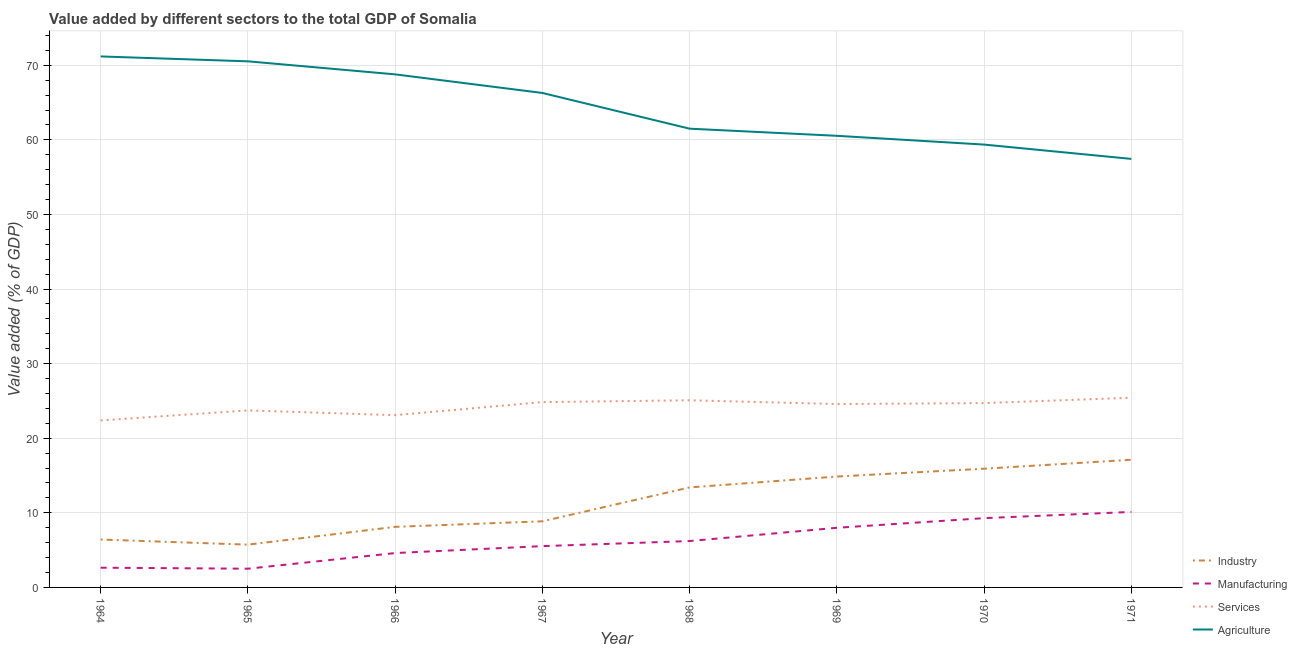How many different coloured lines are there?
Your response must be concise. 4. Does the line corresponding to value added by industrial sector intersect with the line corresponding to value added by manufacturing sector?
Keep it short and to the point. No. What is the value added by manufacturing sector in 1965?
Make the answer very short. 2.51. Across all years, what is the maximum value added by industrial sector?
Make the answer very short. 17.12. Across all years, what is the minimum value added by agricultural sector?
Give a very brief answer. 57.45. In which year was the value added by industrial sector maximum?
Make the answer very short. 1971. In which year was the value added by services sector minimum?
Give a very brief answer. 1964. What is the total value added by agricultural sector in the graph?
Your answer should be very brief. 515.66. What is the difference between the value added by services sector in 1965 and that in 1968?
Provide a succinct answer. -1.36. What is the difference between the value added by manufacturing sector in 1967 and the value added by services sector in 1970?
Your answer should be very brief. -19.17. What is the average value added by agricultural sector per year?
Provide a succinct answer. 64.46. In the year 1966, what is the difference between the value added by industrial sector and value added by services sector?
Provide a succinct answer. -14.97. What is the ratio of the value added by industrial sector in 1967 to that in 1970?
Ensure brevity in your answer.  0.56. What is the difference between the highest and the second highest value added by manufacturing sector?
Offer a very short reply. 0.83. What is the difference between the highest and the lowest value added by manufacturing sector?
Keep it short and to the point. 7.61. Is the sum of the value added by agricultural sector in 1964 and 1970 greater than the maximum value added by manufacturing sector across all years?
Provide a succinct answer. Yes. Is it the case that in every year, the sum of the value added by industrial sector and value added by agricultural sector is greater than the sum of value added by services sector and value added by manufacturing sector?
Provide a succinct answer. No. Does the value added by manufacturing sector monotonically increase over the years?
Your answer should be very brief. No. Are the values on the major ticks of Y-axis written in scientific E-notation?
Provide a succinct answer. No. Does the graph contain any zero values?
Make the answer very short. No. Does the graph contain grids?
Your answer should be compact. Yes. How many legend labels are there?
Make the answer very short. 4. What is the title of the graph?
Your response must be concise. Value added by different sectors to the total GDP of Somalia. Does "Japan" appear as one of the legend labels in the graph?
Make the answer very short. No. What is the label or title of the Y-axis?
Provide a short and direct response. Value added (% of GDP). What is the Value added (% of GDP) of Industry in 1964?
Provide a succinct answer. 6.42. What is the Value added (% of GDP) in Manufacturing in 1964?
Provide a succinct answer. 2.65. What is the Value added (% of GDP) in Services in 1964?
Make the answer very short. 22.39. What is the Value added (% of GDP) of Agriculture in 1964?
Make the answer very short. 71.19. What is the Value added (% of GDP) in Industry in 1965?
Give a very brief answer. 5.74. What is the Value added (% of GDP) in Manufacturing in 1965?
Give a very brief answer. 2.51. What is the Value added (% of GDP) of Services in 1965?
Provide a short and direct response. 23.73. What is the Value added (% of GDP) in Agriculture in 1965?
Offer a very short reply. 70.53. What is the Value added (% of GDP) in Industry in 1966?
Offer a very short reply. 8.12. What is the Value added (% of GDP) of Manufacturing in 1966?
Your response must be concise. 4.61. What is the Value added (% of GDP) in Services in 1966?
Give a very brief answer. 23.1. What is the Value added (% of GDP) in Agriculture in 1966?
Make the answer very short. 68.78. What is the Value added (% of GDP) of Industry in 1967?
Make the answer very short. 8.86. What is the Value added (% of GDP) of Manufacturing in 1967?
Offer a very short reply. 5.54. What is the Value added (% of GDP) in Services in 1967?
Make the answer very short. 24.85. What is the Value added (% of GDP) of Agriculture in 1967?
Your answer should be very brief. 66.29. What is the Value added (% of GDP) in Industry in 1968?
Provide a short and direct response. 13.41. What is the Value added (% of GDP) in Manufacturing in 1968?
Your answer should be compact. 6.22. What is the Value added (% of GDP) of Services in 1968?
Offer a terse response. 25.09. What is the Value added (% of GDP) in Agriculture in 1968?
Offer a very short reply. 61.5. What is the Value added (% of GDP) of Industry in 1969?
Your answer should be compact. 14.87. What is the Value added (% of GDP) in Manufacturing in 1969?
Make the answer very short. 7.99. What is the Value added (% of GDP) of Services in 1969?
Make the answer very short. 24.59. What is the Value added (% of GDP) in Agriculture in 1969?
Ensure brevity in your answer.  60.55. What is the Value added (% of GDP) of Industry in 1970?
Provide a short and direct response. 15.92. What is the Value added (% of GDP) of Manufacturing in 1970?
Keep it short and to the point. 9.29. What is the Value added (% of GDP) of Services in 1970?
Offer a very short reply. 24.71. What is the Value added (% of GDP) in Agriculture in 1970?
Offer a very short reply. 59.37. What is the Value added (% of GDP) of Industry in 1971?
Your response must be concise. 17.12. What is the Value added (% of GDP) of Manufacturing in 1971?
Ensure brevity in your answer.  10.12. What is the Value added (% of GDP) in Services in 1971?
Ensure brevity in your answer.  25.43. What is the Value added (% of GDP) in Agriculture in 1971?
Ensure brevity in your answer.  57.45. Across all years, what is the maximum Value added (% of GDP) of Industry?
Make the answer very short. 17.12. Across all years, what is the maximum Value added (% of GDP) of Manufacturing?
Give a very brief answer. 10.12. Across all years, what is the maximum Value added (% of GDP) of Services?
Ensure brevity in your answer.  25.43. Across all years, what is the maximum Value added (% of GDP) of Agriculture?
Ensure brevity in your answer.  71.19. Across all years, what is the minimum Value added (% of GDP) in Industry?
Offer a very short reply. 5.74. Across all years, what is the minimum Value added (% of GDP) of Manufacturing?
Make the answer very short. 2.51. Across all years, what is the minimum Value added (% of GDP) in Services?
Provide a succinct answer. 22.39. Across all years, what is the minimum Value added (% of GDP) in Agriculture?
Your response must be concise. 57.45. What is the total Value added (% of GDP) of Industry in the graph?
Your answer should be compact. 90.45. What is the total Value added (% of GDP) of Manufacturing in the graph?
Offer a terse response. 48.92. What is the total Value added (% of GDP) in Services in the graph?
Provide a succinct answer. 193.89. What is the total Value added (% of GDP) in Agriculture in the graph?
Offer a terse response. 515.66. What is the difference between the Value added (% of GDP) of Industry in 1964 and that in 1965?
Your answer should be compact. 0.69. What is the difference between the Value added (% of GDP) in Manufacturing in 1964 and that in 1965?
Give a very brief answer. 0.14. What is the difference between the Value added (% of GDP) of Services in 1964 and that in 1965?
Give a very brief answer. -1.34. What is the difference between the Value added (% of GDP) of Agriculture in 1964 and that in 1965?
Make the answer very short. 0.65. What is the difference between the Value added (% of GDP) in Industry in 1964 and that in 1966?
Give a very brief answer. -1.7. What is the difference between the Value added (% of GDP) in Manufacturing in 1964 and that in 1966?
Offer a very short reply. -1.96. What is the difference between the Value added (% of GDP) of Services in 1964 and that in 1966?
Offer a terse response. -0.7. What is the difference between the Value added (% of GDP) in Agriculture in 1964 and that in 1966?
Provide a short and direct response. 2.4. What is the difference between the Value added (% of GDP) of Industry in 1964 and that in 1967?
Your answer should be very brief. -2.44. What is the difference between the Value added (% of GDP) in Manufacturing in 1964 and that in 1967?
Your answer should be very brief. -2.89. What is the difference between the Value added (% of GDP) of Services in 1964 and that in 1967?
Your answer should be very brief. -2.45. What is the difference between the Value added (% of GDP) in Agriculture in 1964 and that in 1967?
Make the answer very short. 4.9. What is the difference between the Value added (% of GDP) in Industry in 1964 and that in 1968?
Provide a succinct answer. -6.99. What is the difference between the Value added (% of GDP) of Manufacturing in 1964 and that in 1968?
Provide a succinct answer. -3.57. What is the difference between the Value added (% of GDP) in Services in 1964 and that in 1968?
Offer a very short reply. -2.7. What is the difference between the Value added (% of GDP) in Agriculture in 1964 and that in 1968?
Provide a succinct answer. 9.68. What is the difference between the Value added (% of GDP) of Industry in 1964 and that in 1969?
Your answer should be compact. -8.45. What is the difference between the Value added (% of GDP) in Manufacturing in 1964 and that in 1969?
Offer a terse response. -5.35. What is the difference between the Value added (% of GDP) of Services in 1964 and that in 1969?
Make the answer very short. -2.2. What is the difference between the Value added (% of GDP) of Agriculture in 1964 and that in 1969?
Provide a succinct answer. 10.64. What is the difference between the Value added (% of GDP) of Industry in 1964 and that in 1970?
Ensure brevity in your answer.  -9.5. What is the difference between the Value added (% of GDP) of Manufacturing in 1964 and that in 1970?
Provide a succinct answer. -6.64. What is the difference between the Value added (% of GDP) of Services in 1964 and that in 1970?
Your answer should be compact. -2.32. What is the difference between the Value added (% of GDP) in Agriculture in 1964 and that in 1970?
Offer a terse response. 11.82. What is the difference between the Value added (% of GDP) of Industry in 1964 and that in 1971?
Ensure brevity in your answer.  -10.69. What is the difference between the Value added (% of GDP) in Manufacturing in 1964 and that in 1971?
Offer a very short reply. -7.48. What is the difference between the Value added (% of GDP) of Services in 1964 and that in 1971?
Offer a very short reply. -3.04. What is the difference between the Value added (% of GDP) of Agriculture in 1964 and that in 1971?
Ensure brevity in your answer.  13.74. What is the difference between the Value added (% of GDP) of Industry in 1965 and that in 1966?
Give a very brief answer. -2.39. What is the difference between the Value added (% of GDP) in Manufacturing in 1965 and that in 1966?
Provide a succinct answer. -2.1. What is the difference between the Value added (% of GDP) in Services in 1965 and that in 1966?
Provide a short and direct response. 0.64. What is the difference between the Value added (% of GDP) of Agriculture in 1965 and that in 1966?
Your response must be concise. 1.75. What is the difference between the Value added (% of GDP) in Industry in 1965 and that in 1967?
Your answer should be very brief. -3.13. What is the difference between the Value added (% of GDP) in Manufacturing in 1965 and that in 1967?
Your response must be concise. -3.03. What is the difference between the Value added (% of GDP) of Services in 1965 and that in 1967?
Provide a short and direct response. -1.11. What is the difference between the Value added (% of GDP) of Agriculture in 1965 and that in 1967?
Ensure brevity in your answer.  4.24. What is the difference between the Value added (% of GDP) in Industry in 1965 and that in 1968?
Provide a short and direct response. -7.67. What is the difference between the Value added (% of GDP) of Manufacturing in 1965 and that in 1968?
Provide a succinct answer. -3.71. What is the difference between the Value added (% of GDP) in Services in 1965 and that in 1968?
Provide a short and direct response. -1.36. What is the difference between the Value added (% of GDP) of Agriculture in 1965 and that in 1968?
Your response must be concise. 9.03. What is the difference between the Value added (% of GDP) of Industry in 1965 and that in 1969?
Give a very brief answer. -9.13. What is the difference between the Value added (% of GDP) of Manufacturing in 1965 and that in 1969?
Your answer should be compact. -5.49. What is the difference between the Value added (% of GDP) of Services in 1965 and that in 1969?
Keep it short and to the point. -0.86. What is the difference between the Value added (% of GDP) of Agriculture in 1965 and that in 1969?
Offer a very short reply. 9.99. What is the difference between the Value added (% of GDP) of Industry in 1965 and that in 1970?
Keep it short and to the point. -10.18. What is the difference between the Value added (% of GDP) in Manufacturing in 1965 and that in 1970?
Give a very brief answer. -6.78. What is the difference between the Value added (% of GDP) of Services in 1965 and that in 1970?
Your answer should be very brief. -0.98. What is the difference between the Value added (% of GDP) in Agriculture in 1965 and that in 1970?
Offer a terse response. 11.16. What is the difference between the Value added (% of GDP) of Industry in 1965 and that in 1971?
Provide a short and direct response. -11.38. What is the difference between the Value added (% of GDP) of Manufacturing in 1965 and that in 1971?
Your response must be concise. -7.61. What is the difference between the Value added (% of GDP) of Services in 1965 and that in 1971?
Ensure brevity in your answer.  -1.7. What is the difference between the Value added (% of GDP) of Agriculture in 1965 and that in 1971?
Give a very brief answer. 13.08. What is the difference between the Value added (% of GDP) in Industry in 1966 and that in 1967?
Offer a very short reply. -0.74. What is the difference between the Value added (% of GDP) in Manufacturing in 1966 and that in 1967?
Give a very brief answer. -0.93. What is the difference between the Value added (% of GDP) in Services in 1966 and that in 1967?
Keep it short and to the point. -1.75. What is the difference between the Value added (% of GDP) of Agriculture in 1966 and that in 1967?
Provide a short and direct response. 2.49. What is the difference between the Value added (% of GDP) in Industry in 1966 and that in 1968?
Provide a short and direct response. -5.29. What is the difference between the Value added (% of GDP) of Manufacturing in 1966 and that in 1968?
Make the answer very short. -1.61. What is the difference between the Value added (% of GDP) in Services in 1966 and that in 1968?
Keep it short and to the point. -1.99. What is the difference between the Value added (% of GDP) of Agriculture in 1966 and that in 1968?
Your response must be concise. 7.28. What is the difference between the Value added (% of GDP) in Industry in 1966 and that in 1969?
Your answer should be compact. -6.74. What is the difference between the Value added (% of GDP) of Manufacturing in 1966 and that in 1969?
Your answer should be compact. -3.39. What is the difference between the Value added (% of GDP) of Services in 1966 and that in 1969?
Your response must be concise. -1.49. What is the difference between the Value added (% of GDP) of Agriculture in 1966 and that in 1969?
Keep it short and to the point. 8.24. What is the difference between the Value added (% of GDP) of Industry in 1966 and that in 1970?
Keep it short and to the point. -7.8. What is the difference between the Value added (% of GDP) of Manufacturing in 1966 and that in 1970?
Provide a short and direct response. -4.68. What is the difference between the Value added (% of GDP) of Services in 1966 and that in 1970?
Your answer should be very brief. -1.62. What is the difference between the Value added (% of GDP) of Agriculture in 1966 and that in 1970?
Give a very brief answer. 9.41. What is the difference between the Value added (% of GDP) in Industry in 1966 and that in 1971?
Your response must be concise. -8.99. What is the difference between the Value added (% of GDP) in Manufacturing in 1966 and that in 1971?
Your answer should be very brief. -5.51. What is the difference between the Value added (% of GDP) of Services in 1966 and that in 1971?
Ensure brevity in your answer.  -2.34. What is the difference between the Value added (% of GDP) in Agriculture in 1966 and that in 1971?
Make the answer very short. 11.33. What is the difference between the Value added (% of GDP) in Industry in 1967 and that in 1968?
Your response must be concise. -4.54. What is the difference between the Value added (% of GDP) of Manufacturing in 1967 and that in 1968?
Offer a terse response. -0.68. What is the difference between the Value added (% of GDP) in Services in 1967 and that in 1968?
Offer a terse response. -0.24. What is the difference between the Value added (% of GDP) in Agriculture in 1967 and that in 1968?
Make the answer very short. 4.79. What is the difference between the Value added (% of GDP) in Industry in 1967 and that in 1969?
Keep it short and to the point. -6. What is the difference between the Value added (% of GDP) in Manufacturing in 1967 and that in 1969?
Your answer should be very brief. -2.46. What is the difference between the Value added (% of GDP) in Services in 1967 and that in 1969?
Offer a very short reply. 0.26. What is the difference between the Value added (% of GDP) of Agriculture in 1967 and that in 1969?
Your answer should be compact. 5.75. What is the difference between the Value added (% of GDP) in Industry in 1967 and that in 1970?
Ensure brevity in your answer.  -7.05. What is the difference between the Value added (% of GDP) in Manufacturing in 1967 and that in 1970?
Make the answer very short. -3.75. What is the difference between the Value added (% of GDP) of Services in 1967 and that in 1970?
Give a very brief answer. 0.13. What is the difference between the Value added (% of GDP) in Agriculture in 1967 and that in 1970?
Give a very brief answer. 6.92. What is the difference between the Value added (% of GDP) of Industry in 1967 and that in 1971?
Provide a short and direct response. -8.25. What is the difference between the Value added (% of GDP) of Manufacturing in 1967 and that in 1971?
Your response must be concise. -4.59. What is the difference between the Value added (% of GDP) in Services in 1967 and that in 1971?
Ensure brevity in your answer.  -0.59. What is the difference between the Value added (% of GDP) of Agriculture in 1967 and that in 1971?
Provide a short and direct response. 8.84. What is the difference between the Value added (% of GDP) in Industry in 1968 and that in 1969?
Make the answer very short. -1.46. What is the difference between the Value added (% of GDP) in Manufacturing in 1968 and that in 1969?
Ensure brevity in your answer.  -1.78. What is the difference between the Value added (% of GDP) in Services in 1968 and that in 1969?
Offer a terse response. 0.5. What is the difference between the Value added (% of GDP) of Agriculture in 1968 and that in 1969?
Keep it short and to the point. 0.96. What is the difference between the Value added (% of GDP) in Industry in 1968 and that in 1970?
Ensure brevity in your answer.  -2.51. What is the difference between the Value added (% of GDP) in Manufacturing in 1968 and that in 1970?
Ensure brevity in your answer.  -3.07. What is the difference between the Value added (% of GDP) of Services in 1968 and that in 1970?
Ensure brevity in your answer.  0.38. What is the difference between the Value added (% of GDP) of Agriculture in 1968 and that in 1970?
Provide a succinct answer. 2.13. What is the difference between the Value added (% of GDP) of Industry in 1968 and that in 1971?
Offer a terse response. -3.71. What is the difference between the Value added (% of GDP) in Manufacturing in 1968 and that in 1971?
Provide a succinct answer. -3.91. What is the difference between the Value added (% of GDP) in Services in 1968 and that in 1971?
Ensure brevity in your answer.  -0.34. What is the difference between the Value added (% of GDP) in Agriculture in 1968 and that in 1971?
Give a very brief answer. 4.05. What is the difference between the Value added (% of GDP) in Industry in 1969 and that in 1970?
Ensure brevity in your answer.  -1.05. What is the difference between the Value added (% of GDP) of Manufacturing in 1969 and that in 1970?
Your response must be concise. -1.29. What is the difference between the Value added (% of GDP) of Services in 1969 and that in 1970?
Your response must be concise. -0.12. What is the difference between the Value added (% of GDP) in Agriculture in 1969 and that in 1970?
Provide a short and direct response. 1.17. What is the difference between the Value added (% of GDP) of Industry in 1969 and that in 1971?
Keep it short and to the point. -2.25. What is the difference between the Value added (% of GDP) of Manufacturing in 1969 and that in 1971?
Your response must be concise. -2.13. What is the difference between the Value added (% of GDP) in Services in 1969 and that in 1971?
Your answer should be compact. -0.84. What is the difference between the Value added (% of GDP) in Agriculture in 1969 and that in 1971?
Ensure brevity in your answer.  3.09. What is the difference between the Value added (% of GDP) of Industry in 1970 and that in 1971?
Offer a very short reply. -1.2. What is the difference between the Value added (% of GDP) of Manufacturing in 1970 and that in 1971?
Give a very brief answer. -0.83. What is the difference between the Value added (% of GDP) of Services in 1970 and that in 1971?
Provide a succinct answer. -0.72. What is the difference between the Value added (% of GDP) of Agriculture in 1970 and that in 1971?
Your answer should be compact. 1.92. What is the difference between the Value added (% of GDP) of Industry in 1964 and the Value added (% of GDP) of Manufacturing in 1965?
Offer a terse response. 3.91. What is the difference between the Value added (% of GDP) in Industry in 1964 and the Value added (% of GDP) in Services in 1965?
Your response must be concise. -17.31. What is the difference between the Value added (% of GDP) of Industry in 1964 and the Value added (% of GDP) of Agriculture in 1965?
Ensure brevity in your answer.  -64.11. What is the difference between the Value added (% of GDP) in Manufacturing in 1964 and the Value added (% of GDP) in Services in 1965?
Offer a very short reply. -21.09. What is the difference between the Value added (% of GDP) in Manufacturing in 1964 and the Value added (% of GDP) in Agriculture in 1965?
Provide a succinct answer. -67.89. What is the difference between the Value added (% of GDP) of Services in 1964 and the Value added (% of GDP) of Agriculture in 1965?
Give a very brief answer. -48.14. What is the difference between the Value added (% of GDP) of Industry in 1964 and the Value added (% of GDP) of Manufacturing in 1966?
Provide a succinct answer. 1.81. What is the difference between the Value added (% of GDP) of Industry in 1964 and the Value added (% of GDP) of Services in 1966?
Provide a short and direct response. -16.67. What is the difference between the Value added (% of GDP) in Industry in 1964 and the Value added (% of GDP) in Agriculture in 1966?
Keep it short and to the point. -62.36. What is the difference between the Value added (% of GDP) of Manufacturing in 1964 and the Value added (% of GDP) of Services in 1966?
Provide a short and direct response. -20.45. What is the difference between the Value added (% of GDP) of Manufacturing in 1964 and the Value added (% of GDP) of Agriculture in 1966?
Offer a very short reply. -66.14. What is the difference between the Value added (% of GDP) in Services in 1964 and the Value added (% of GDP) in Agriculture in 1966?
Your answer should be compact. -46.39. What is the difference between the Value added (% of GDP) in Industry in 1964 and the Value added (% of GDP) in Manufacturing in 1967?
Your answer should be compact. 0.88. What is the difference between the Value added (% of GDP) of Industry in 1964 and the Value added (% of GDP) of Services in 1967?
Provide a succinct answer. -18.42. What is the difference between the Value added (% of GDP) of Industry in 1964 and the Value added (% of GDP) of Agriculture in 1967?
Keep it short and to the point. -59.87. What is the difference between the Value added (% of GDP) in Manufacturing in 1964 and the Value added (% of GDP) in Services in 1967?
Your response must be concise. -22.2. What is the difference between the Value added (% of GDP) of Manufacturing in 1964 and the Value added (% of GDP) of Agriculture in 1967?
Provide a succinct answer. -63.65. What is the difference between the Value added (% of GDP) in Services in 1964 and the Value added (% of GDP) in Agriculture in 1967?
Your answer should be compact. -43.9. What is the difference between the Value added (% of GDP) of Industry in 1964 and the Value added (% of GDP) of Manufacturing in 1968?
Your answer should be very brief. 0.2. What is the difference between the Value added (% of GDP) of Industry in 1964 and the Value added (% of GDP) of Services in 1968?
Your answer should be compact. -18.67. What is the difference between the Value added (% of GDP) of Industry in 1964 and the Value added (% of GDP) of Agriculture in 1968?
Your response must be concise. -55.08. What is the difference between the Value added (% of GDP) of Manufacturing in 1964 and the Value added (% of GDP) of Services in 1968?
Offer a very short reply. -22.44. What is the difference between the Value added (% of GDP) of Manufacturing in 1964 and the Value added (% of GDP) of Agriculture in 1968?
Your answer should be compact. -58.86. What is the difference between the Value added (% of GDP) of Services in 1964 and the Value added (% of GDP) of Agriculture in 1968?
Make the answer very short. -39.11. What is the difference between the Value added (% of GDP) in Industry in 1964 and the Value added (% of GDP) in Manufacturing in 1969?
Your answer should be compact. -1.57. What is the difference between the Value added (% of GDP) in Industry in 1964 and the Value added (% of GDP) in Services in 1969?
Your answer should be compact. -18.17. What is the difference between the Value added (% of GDP) in Industry in 1964 and the Value added (% of GDP) in Agriculture in 1969?
Your answer should be compact. -54.12. What is the difference between the Value added (% of GDP) in Manufacturing in 1964 and the Value added (% of GDP) in Services in 1969?
Ensure brevity in your answer.  -21.94. What is the difference between the Value added (% of GDP) of Manufacturing in 1964 and the Value added (% of GDP) of Agriculture in 1969?
Your answer should be compact. -57.9. What is the difference between the Value added (% of GDP) in Services in 1964 and the Value added (% of GDP) in Agriculture in 1969?
Make the answer very short. -38.15. What is the difference between the Value added (% of GDP) of Industry in 1964 and the Value added (% of GDP) of Manufacturing in 1970?
Offer a very short reply. -2.87. What is the difference between the Value added (% of GDP) of Industry in 1964 and the Value added (% of GDP) of Services in 1970?
Offer a very short reply. -18.29. What is the difference between the Value added (% of GDP) of Industry in 1964 and the Value added (% of GDP) of Agriculture in 1970?
Give a very brief answer. -52.95. What is the difference between the Value added (% of GDP) of Manufacturing in 1964 and the Value added (% of GDP) of Services in 1970?
Offer a terse response. -22.07. What is the difference between the Value added (% of GDP) in Manufacturing in 1964 and the Value added (% of GDP) in Agriculture in 1970?
Provide a short and direct response. -56.73. What is the difference between the Value added (% of GDP) in Services in 1964 and the Value added (% of GDP) in Agriculture in 1970?
Your answer should be compact. -36.98. What is the difference between the Value added (% of GDP) in Industry in 1964 and the Value added (% of GDP) in Manufacturing in 1971?
Give a very brief answer. -3.7. What is the difference between the Value added (% of GDP) in Industry in 1964 and the Value added (% of GDP) in Services in 1971?
Make the answer very short. -19.01. What is the difference between the Value added (% of GDP) of Industry in 1964 and the Value added (% of GDP) of Agriculture in 1971?
Give a very brief answer. -51.03. What is the difference between the Value added (% of GDP) of Manufacturing in 1964 and the Value added (% of GDP) of Services in 1971?
Give a very brief answer. -22.79. What is the difference between the Value added (% of GDP) in Manufacturing in 1964 and the Value added (% of GDP) in Agriculture in 1971?
Your answer should be very brief. -54.81. What is the difference between the Value added (% of GDP) of Services in 1964 and the Value added (% of GDP) of Agriculture in 1971?
Ensure brevity in your answer.  -35.06. What is the difference between the Value added (% of GDP) of Industry in 1965 and the Value added (% of GDP) of Manufacturing in 1966?
Give a very brief answer. 1.13. What is the difference between the Value added (% of GDP) in Industry in 1965 and the Value added (% of GDP) in Services in 1966?
Your answer should be compact. -17.36. What is the difference between the Value added (% of GDP) in Industry in 1965 and the Value added (% of GDP) in Agriculture in 1966?
Your answer should be compact. -63.05. What is the difference between the Value added (% of GDP) in Manufacturing in 1965 and the Value added (% of GDP) in Services in 1966?
Your response must be concise. -20.59. What is the difference between the Value added (% of GDP) of Manufacturing in 1965 and the Value added (% of GDP) of Agriculture in 1966?
Keep it short and to the point. -66.27. What is the difference between the Value added (% of GDP) of Services in 1965 and the Value added (% of GDP) of Agriculture in 1966?
Your response must be concise. -45.05. What is the difference between the Value added (% of GDP) in Industry in 1965 and the Value added (% of GDP) in Manufacturing in 1967?
Ensure brevity in your answer.  0.2. What is the difference between the Value added (% of GDP) in Industry in 1965 and the Value added (% of GDP) in Services in 1967?
Give a very brief answer. -19.11. What is the difference between the Value added (% of GDP) in Industry in 1965 and the Value added (% of GDP) in Agriculture in 1967?
Make the answer very short. -60.56. What is the difference between the Value added (% of GDP) of Manufacturing in 1965 and the Value added (% of GDP) of Services in 1967?
Offer a terse response. -22.34. What is the difference between the Value added (% of GDP) in Manufacturing in 1965 and the Value added (% of GDP) in Agriculture in 1967?
Make the answer very short. -63.78. What is the difference between the Value added (% of GDP) of Services in 1965 and the Value added (% of GDP) of Agriculture in 1967?
Ensure brevity in your answer.  -42.56. What is the difference between the Value added (% of GDP) in Industry in 1965 and the Value added (% of GDP) in Manufacturing in 1968?
Offer a very short reply. -0.48. What is the difference between the Value added (% of GDP) of Industry in 1965 and the Value added (% of GDP) of Services in 1968?
Provide a succinct answer. -19.35. What is the difference between the Value added (% of GDP) in Industry in 1965 and the Value added (% of GDP) in Agriculture in 1968?
Offer a very short reply. -55.77. What is the difference between the Value added (% of GDP) of Manufacturing in 1965 and the Value added (% of GDP) of Services in 1968?
Offer a terse response. -22.58. What is the difference between the Value added (% of GDP) of Manufacturing in 1965 and the Value added (% of GDP) of Agriculture in 1968?
Your answer should be very brief. -58.99. What is the difference between the Value added (% of GDP) in Services in 1965 and the Value added (% of GDP) in Agriculture in 1968?
Make the answer very short. -37.77. What is the difference between the Value added (% of GDP) of Industry in 1965 and the Value added (% of GDP) of Manufacturing in 1969?
Give a very brief answer. -2.26. What is the difference between the Value added (% of GDP) in Industry in 1965 and the Value added (% of GDP) in Services in 1969?
Your response must be concise. -18.85. What is the difference between the Value added (% of GDP) in Industry in 1965 and the Value added (% of GDP) in Agriculture in 1969?
Offer a terse response. -54.81. What is the difference between the Value added (% of GDP) of Manufacturing in 1965 and the Value added (% of GDP) of Services in 1969?
Your response must be concise. -22.08. What is the difference between the Value added (% of GDP) in Manufacturing in 1965 and the Value added (% of GDP) in Agriculture in 1969?
Provide a short and direct response. -58.04. What is the difference between the Value added (% of GDP) of Services in 1965 and the Value added (% of GDP) of Agriculture in 1969?
Offer a terse response. -36.81. What is the difference between the Value added (% of GDP) in Industry in 1965 and the Value added (% of GDP) in Manufacturing in 1970?
Your answer should be compact. -3.55. What is the difference between the Value added (% of GDP) in Industry in 1965 and the Value added (% of GDP) in Services in 1970?
Provide a short and direct response. -18.98. What is the difference between the Value added (% of GDP) in Industry in 1965 and the Value added (% of GDP) in Agriculture in 1970?
Offer a very short reply. -53.64. What is the difference between the Value added (% of GDP) of Manufacturing in 1965 and the Value added (% of GDP) of Services in 1970?
Your response must be concise. -22.2. What is the difference between the Value added (% of GDP) in Manufacturing in 1965 and the Value added (% of GDP) in Agriculture in 1970?
Provide a succinct answer. -56.86. What is the difference between the Value added (% of GDP) in Services in 1965 and the Value added (% of GDP) in Agriculture in 1970?
Offer a terse response. -35.64. What is the difference between the Value added (% of GDP) in Industry in 1965 and the Value added (% of GDP) in Manufacturing in 1971?
Ensure brevity in your answer.  -4.39. What is the difference between the Value added (% of GDP) of Industry in 1965 and the Value added (% of GDP) of Services in 1971?
Your answer should be very brief. -19.7. What is the difference between the Value added (% of GDP) in Industry in 1965 and the Value added (% of GDP) in Agriculture in 1971?
Offer a terse response. -51.72. What is the difference between the Value added (% of GDP) of Manufacturing in 1965 and the Value added (% of GDP) of Services in 1971?
Your answer should be compact. -22.92. What is the difference between the Value added (% of GDP) of Manufacturing in 1965 and the Value added (% of GDP) of Agriculture in 1971?
Provide a succinct answer. -54.94. What is the difference between the Value added (% of GDP) in Services in 1965 and the Value added (% of GDP) in Agriculture in 1971?
Ensure brevity in your answer.  -33.72. What is the difference between the Value added (% of GDP) of Industry in 1966 and the Value added (% of GDP) of Manufacturing in 1967?
Your answer should be compact. 2.58. What is the difference between the Value added (% of GDP) in Industry in 1966 and the Value added (% of GDP) in Services in 1967?
Your response must be concise. -16.72. What is the difference between the Value added (% of GDP) of Industry in 1966 and the Value added (% of GDP) of Agriculture in 1967?
Keep it short and to the point. -58.17. What is the difference between the Value added (% of GDP) in Manufacturing in 1966 and the Value added (% of GDP) in Services in 1967?
Offer a terse response. -20.24. What is the difference between the Value added (% of GDP) of Manufacturing in 1966 and the Value added (% of GDP) of Agriculture in 1967?
Offer a terse response. -61.68. What is the difference between the Value added (% of GDP) in Services in 1966 and the Value added (% of GDP) in Agriculture in 1967?
Offer a very short reply. -43.2. What is the difference between the Value added (% of GDP) in Industry in 1966 and the Value added (% of GDP) in Manufacturing in 1968?
Your answer should be very brief. 1.9. What is the difference between the Value added (% of GDP) in Industry in 1966 and the Value added (% of GDP) in Services in 1968?
Ensure brevity in your answer.  -16.97. What is the difference between the Value added (% of GDP) in Industry in 1966 and the Value added (% of GDP) in Agriculture in 1968?
Keep it short and to the point. -53.38. What is the difference between the Value added (% of GDP) in Manufacturing in 1966 and the Value added (% of GDP) in Services in 1968?
Ensure brevity in your answer.  -20.48. What is the difference between the Value added (% of GDP) of Manufacturing in 1966 and the Value added (% of GDP) of Agriculture in 1968?
Ensure brevity in your answer.  -56.89. What is the difference between the Value added (% of GDP) in Services in 1966 and the Value added (% of GDP) in Agriculture in 1968?
Provide a short and direct response. -38.41. What is the difference between the Value added (% of GDP) in Industry in 1966 and the Value added (% of GDP) in Manufacturing in 1969?
Ensure brevity in your answer.  0.13. What is the difference between the Value added (% of GDP) in Industry in 1966 and the Value added (% of GDP) in Services in 1969?
Provide a succinct answer. -16.47. What is the difference between the Value added (% of GDP) in Industry in 1966 and the Value added (% of GDP) in Agriculture in 1969?
Provide a succinct answer. -52.42. What is the difference between the Value added (% of GDP) of Manufacturing in 1966 and the Value added (% of GDP) of Services in 1969?
Ensure brevity in your answer.  -19.98. What is the difference between the Value added (% of GDP) in Manufacturing in 1966 and the Value added (% of GDP) in Agriculture in 1969?
Provide a short and direct response. -55.94. What is the difference between the Value added (% of GDP) of Services in 1966 and the Value added (% of GDP) of Agriculture in 1969?
Keep it short and to the point. -37.45. What is the difference between the Value added (% of GDP) of Industry in 1966 and the Value added (% of GDP) of Manufacturing in 1970?
Make the answer very short. -1.17. What is the difference between the Value added (% of GDP) in Industry in 1966 and the Value added (% of GDP) in Services in 1970?
Your answer should be compact. -16.59. What is the difference between the Value added (% of GDP) in Industry in 1966 and the Value added (% of GDP) in Agriculture in 1970?
Provide a succinct answer. -51.25. What is the difference between the Value added (% of GDP) of Manufacturing in 1966 and the Value added (% of GDP) of Services in 1970?
Your answer should be very brief. -20.1. What is the difference between the Value added (% of GDP) of Manufacturing in 1966 and the Value added (% of GDP) of Agriculture in 1970?
Keep it short and to the point. -54.76. What is the difference between the Value added (% of GDP) in Services in 1966 and the Value added (% of GDP) in Agriculture in 1970?
Ensure brevity in your answer.  -36.28. What is the difference between the Value added (% of GDP) in Industry in 1966 and the Value added (% of GDP) in Manufacturing in 1971?
Offer a terse response. -2. What is the difference between the Value added (% of GDP) in Industry in 1966 and the Value added (% of GDP) in Services in 1971?
Your answer should be very brief. -17.31. What is the difference between the Value added (% of GDP) in Industry in 1966 and the Value added (% of GDP) in Agriculture in 1971?
Provide a succinct answer. -49.33. What is the difference between the Value added (% of GDP) in Manufacturing in 1966 and the Value added (% of GDP) in Services in 1971?
Make the answer very short. -20.83. What is the difference between the Value added (% of GDP) in Manufacturing in 1966 and the Value added (% of GDP) in Agriculture in 1971?
Ensure brevity in your answer.  -52.84. What is the difference between the Value added (% of GDP) of Services in 1966 and the Value added (% of GDP) of Agriculture in 1971?
Make the answer very short. -34.36. What is the difference between the Value added (% of GDP) in Industry in 1967 and the Value added (% of GDP) in Manufacturing in 1968?
Your answer should be compact. 2.65. What is the difference between the Value added (% of GDP) of Industry in 1967 and the Value added (% of GDP) of Services in 1968?
Provide a succinct answer. -16.23. What is the difference between the Value added (% of GDP) of Industry in 1967 and the Value added (% of GDP) of Agriculture in 1968?
Give a very brief answer. -52.64. What is the difference between the Value added (% of GDP) of Manufacturing in 1967 and the Value added (% of GDP) of Services in 1968?
Offer a terse response. -19.55. What is the difference between the Value added (% of GDP) in Manufacturing in 1967 and the Value added (% of GDP) in Agriculture in 1968?
Your answer should be very brief. -55.97. What is the difference between the Value added (% of GDP) in Services in 1967 and the Value added (% of GDP) in Agriculture in 1968?
Give a very brief answer. -36.66. What is the difference between the Value added (% of GDP) of Industry in 1967 and the Value added (% of GDP) of Manufacturing in 1969?
Provide a succinct answer. 0.87. What is the difference between the Value added (% of GDP) of Industry in 1967 and the Value added (% of GDP) of Services in 1969?
Provide a succinct answer. -15.72. What is the difference between the Value added (% of GDP) in Industry in 1967 and the Value added (% of GDP) in Agriculture in 1969?
Offer a terse response. -51.68. What is the difference between the Value added (% of GDP) in Manufacturing in 1967 and the Value added (% of GDP) in Services in 1969?
Offer a terse response. -19.05. What is the difference between the Value added (% of GDP) in Manufacturing in 1967 and the Value added (% of GDP) in Agriculture in 1969?
Ensure brevity in your answer.  -55.01. What is the difference between the Value added (% of GDP) of Services in 1967 and the Value added (% of GDP) of Agriculture in 1969?
Ensure brevity in your answer.  -35.7. What is the difference between the Value added (% of GDP) of Industry in 1967 and the Value added (% of GDP) of Manufacturing in 1970?
Give a very brief answer. -0.42. What is the difference between the Value added (% of GDP) in Industry in 1967 and the Value added (% of GDP) in Services in 1970?
Give a very brief answer. -15.85. What is the difference between the Value added (% of GDP) in Industry in 1967 and the Value added (% of GDP) in Agriculture in 1970?
Your response must be concise. -50.51. What is the difference between the Value added (% of GDP) of Manufacturing in 1967 and the Value added (% of GDP) of Services in 1970?
Your answer should be very brief. -19.17. What is the difference between the Value added (% of GDP) of Manufacturing in 1967 and the Value added (% of GDP) of Agriculture in 1970?
Provide a succinct answer. -53.83. What is the difference between the Value added (% of GDP) in Services in 1967 and the Value added (% of GDP) in Agriculture in 1970?
Give a very brief answer. -34.53. What is the difference between the Value added (% of GDP) of Industry in 1967 and the Value added (% of GDP) of Manufacturing in 1971?
Provide a short and direct response. -1.26. What is the difference between the Value added (% of GDP) of Industry in 1967 and the Value added (% of GDP) of Services in 1971?
Make the answer very short. -16.57. What is the difference between the Value added (% of GDP) in Industry in 1967 and the Value added (% of GDP) in Agriculture in 1971?
Your answer should be compact. -48.59. What is the difference between the Value added (% of GDP) in Manufacturing in 1967 and the Value added (% of GDP) in Services in 1971?
Ensure brevity in your answer.  -19.9. What is the difference between the Value added (% of GDP) of Manufacturing in 1967 and the Value added (% of GDP) of Agriculture in 1971?
Offer a terse response. -51.91. What is the difference between the Value added (% of GDP) in Services in 1967 and the Value added (% of GDP) in Agriculture in 1971?
Keep it short and to the point. -32.61. What is the difference between the Value added (% of GDP) of Industry in 1968 and the Value added (% of GDP) of Manufacturing in 1969?
Your response must be concise. 5.41. What is the difference between the Value added (% of GDP) of Industry in 1968 and the Value added (% of GDP) of Services in 1969?
Ensure brevity in your answer.  -11.18. What is the difference between the Value added (% of GDP) of Industry in 1968 and the Value added (% of GDP) of Agriculture in 1969?
Your response must be concise. -47.14. What is the difference between the Value added (% of GDP) in Manufacturing in 1968 and the Value added (% of GDP) in Services in 1969?
Offer a terse response. -18.37. What is the difference between the Value added (% of GDP) of Manufacturing in 1968 and the Value added (% of GDP) of Agriculture in 1969?
Ensure brevity in your answer.  -54.33. What is the difference between the Value added (% of GDP) of Services in 1968 and the Value added (% of GDP) of Agriculture in 1969?
Offer a very short reply. -35.46. What is the difference between the Value added (% of GDP) in Industry in 1968 and the Value added (% of GDP) in Manufacturing in 1970?
Make the answer very short. 4.12. What is the difference between the Value added (% of GDP) in Industry in 1968 and the Value added (% of GDP) in Services in 1970?
Offer a terse response. -11.3. What is the difference between the Value added (% of GDP) in Industry in 1968 and the Value added (% of GDP) in Agriculture in 1970?
Keep it short and to the point. -45.96. What is the difference between the Value added (% of GDP) of Manufacturing in 1968 and the Value added (% of GDP) of Services in 1970?
Provide a succinct answer. -18.49. What is the difference between the Value added (% of GDP) of Manufacturing in 1968 and the Value added (% of GDP) of Agriculture in 1970?
Keep it short and to the point. -53.15. What is the difference between the Value added (% of GDP) in Services in 1968 and the Value added (% of GDP) in Agriculture in 1970?
Your answer should be compact. -34.28. What is the difference between the Value added (% of GDP) in Industry in 1968 and the Value added (% of GDP) in Manufacturing in 1971?
Provide a short and direct response. 3.29. What is the difference between the Value added (% of GDP) of Industry in 1968 and the Value added (% of GDP) of Services in 1971?
Your answer should be very brief. -12.03. What is the difference between the Value added (% of GDP) in Industry in 1968 and the Value added (% of GDP) in Agriculture in 1971?
Offer a terse response. -44.04. What is the difference between the Value added (% of GDP) in Manufacturing in 1968 and the Value added (% of GDP) in Services in 1971?
Your response must be concise. -19.22. What is the difference between the Value added (% of GDP) in Manufacturing in 1968 and the Value added (% of GDP) in Agriculture in 1971?
Your answer should be compact. -51.23. What is the difference between the Value added (% of GDP) of Services in 1968 and the Value added (% of GDP) of Agriculture in 1971?
Keep it short and to the point. -32.36. What is the difference between the Value added (% of GDP) of Industry in 1969 and the Value added (% of GDP) of Manufacturing in 1970?
Provide a succinct answer. 5.58. What is the difference between the Value added (% of GDP) of Industry in 1969 and the Value added (% of GDP) of Services in 1970?
Ensure brevity in your answer.  -9.85. What is the difference between the Value added (% of GDP) in Industry in 1969 and the Value added (% of GDP) in Agriculture in 1970?
Your answer should be very brief. -44.5. What is the difference between the Value added (% of GDP) in Manufacturing in 1969 and the Value added (% of GDP) in Services in 1970?
Keep it short and to the point. -16.72. What is the difference between the Value added (% of GDP) in Manufacturing in 1969 and the Value added (% of GDP) in Agriculture in 1970?
Provide a short and direct response. -51.38. What is the difference between the Value added (% of GDP) in Services in 1969 and the Value added (% of GDP) in Agriculture in 1970?
Your response must be concise. -34.78. What is the difference between the Value added (% of GDP) in Industry in 1969 and the Value added (% of GDP) in Manufacturing in 1971?
Offer a very short reply. 4.74. What is the difference between the Value added (% of GDP) in Industry in 1969 and the Value added (% of GDP) in Services in 1971?
Offer a terse response. -10.57. What is the difference between the Value added (% of GDP) of Industry in 1969 and the Value added (% of GDP) of Agriculture in 1971?
Ensure brevity in your answer.  -42.59. What is the difference between the Value added (% of GDP) in Manufacturing in 1969 and the Value added (% of GDP) in Services in 1971?
Give a very brief answer. -17.44. What is the difference between the Value added (% of GDP) of Manufacturing in 1969 and the Value added (% of GDP) of Agriculture in 1971?
Ensure brevity in your answer.  -49.46. What is the difference between the Value added (% of GDP) of Services in 1969 and the Value added (% of GDP) of Agriculture in 1971?
Offer a very short reply. -32.86. What is the difference between the Value added (% of GDP) in Industry in 1970 and the Value added (% of GDP) in Manufacturing in 1971?
Offer a very short reply. 5.8. What is the difference between the Value added (% of GDP) of Industry in 1970 and the Value added (% of GDP) of Services in 1971?
Your answer should be very brief. -9.52. What is the difference between the Value added (% of GDP) of Industry in 1970 and the Value added (% of GDP) of Agriculture in 1971?
Offer a terse response. -41.53. What is the difference between the Value added (% of GDP) in Manufacturing in 1970 and the Value added (% of GDP) in Services in 1971?
Provide a short and direct response. -16.15. What is the difference between the Value added (% of GDP) in Manufacturing in 1970 and the Value added (% of GDP) in Agriculture in 1971?
Your response must be concise. -48.16. What is the difference between the Value added (% of GDP) of Services in 1970 and the Value added (% of GDP) of Agriculture in 1971?
Your response must be concise. -32.74. What is the average Value added (% of GDP) in Industry per year?
Keep it short and to the point. 11.31. What is the average Value added (% of GDP) in Manufacturing per year?
Make the answer very short. 6.12. What is the average Value added (% of GDP) in Services per year?
Your response must be concise. 24.24. What is the average Value added (% of GDP) of Agriculture per year?
Offer a terse response. 64.46. In the year 1964, what is the difference between the Value added (% of GDP) in Industry and Value added (% of GDP) in Manufacturing?
Ensure brevity in your answer.  3.78. In the year 1964, what is the difference between the Value added (% of GDP) in Industry and Value added (% of GDP) in Services?
Your response must be concise. -15.97. In the year 1964, what is the difference between the Value added (% of GDP) in Industry and Value added (% of GDP) in Agriculture?
Ensure brevity in your answer.  -64.77. In the year 1964, what is the difference between the Value added (% of GDP) of Manufacturing and Value added (% of GDP) of Services?
Offer a very short reply. -19.75. In the year 1964, what is the difference between the Value added (% of GDP) of Manufacturing and Value added (% of GDP) of Agriculture?
Keep it short and to the point. -68.54. In the year 1964, what is the difference between the Value added (% of GDP) in Services and Value added (% of GDP) in Agriculture?
Your answer should be compact. -48.8. In the year 1965, what is the difference between the Value added (% of GDP) in Industry and Value added (% of GDP) in Manufacturing?
Your response must be concise. 3.23. In the year 1965, what is the difference between the Value added (% of GDP) of Industry and Value added (% of GDP) of Services?
Offer a terse response. -18. In the year 1965, what is the difference between the Value added (% of GDP) of Industry and Value added (% of GDP) of Agriculture?
Give a very brief answer. -64.8. In the year 1965, what is the difference between the Value added (% of GDP) of Manufacturing and Value added (% of GDP) of Services?
Offer a very short reply. -21.22. In the year 1965, what is the difference between the Value added (% of GDP) in Manufacturing and Value added (% of GDP) in Agriculture?
Provide a succinct answer. -68.02. In the year 1965, what is the difference between the Value added (% of GDP) of Services and Value added (% of GDP) of Agriculture?
Your answer should be compact. -46.8. In the year 1966, what is the difference between the Value added (% of GDP) of Industry and Value added (% of GDP) of Manufacturing?
Provide a succinct answer. 3.51. In the year 1966, what is the difference between the Value added (% of GDP) of Industry and Value added (% of GDP) of Services?
Provide a succinct answer. -14.97. In the year 1966, what is the difference between the Value added (% of GDP) in Industry and Value added (% of GDP) in Agriculture?
Provide a succinct answer. -60.66. In the year 1966, what is the difference between the Value added (% of GDP) in Manufacturing and Value added (% of GDP) in Services?
Offer a very short reply. -18.49. In the year 1966, what is the difference between the Value added (% of GDP) in Manufacturing and Value added (% of GDP) in Agriculture?
Keep it short and to the point. -64.18. In the year 1966, what is the difference between the Value added (% of GDP) in Services and Value added (% of GDP) in Agriculture?
Your answer should be compact. -45.69. In the year 1967, what is the difference between the Value added (% of GDP) in Industry and Value added (% of GDP) in Manufacturing?
Provide a short and direct response. 3.33. In the year 1967, what is the difference between the Value added (% of GDP) of Industry and Value added (% of GDP) of Services?
Provide a succinct answer. -15.98. In the year 1967, what is the difference between the Value added (% of GDP) of Industry and Value added (% of GDP) of Agriculture?
Keep it short and to the point. -57.43. In the year 1967, what is the difference between the Value added (% of GDP) of Manufacturing and Value added (% of GDP) of Services?
Your answer should be very brief. -19.31. In the year 1967, what is the difference between the Value added (% of GDP) in Manufacturing and Value added (% of GDP) in Agriculture?
Provide a short and direct response. -60.75. In the year 1967, what is the difference between the Value added (% of GDP) of Services and Value added (% of GDP) of Agriculture?
Your answer should be very brief. -41.45. In the year 1968, what is the difference between the Value added (% of GDP) in Industry and Value added (% of GDP) in Manufacturing?
Offer a terse response. 7.19. In the year 1968, what is the difference between the Value added (% of GDP) of Industry and Value added (% of GDP) of Services?
Give a very brief answer. -11.68. In the year 1968, what is the difference between the Value added (% of GDP) in Industry and Value added (% of GDP) in Agriculture?
Make the answer very short. -48.1. In the year 1968, what is the difference between the Value added (% of GDP) of Manufacturing and Value added (% of GDP) of Services?
Offer a very short reply. -18.87. In the year 1968, what is the difference between the Value added (% of GDP) in Manufacturing and Value added (% of GDP) in Agriculture?
Make the answer very short. -55.29. In the year 1968, what is the difference between the Value added (% of GDP) in Services and Value added (% of GDP) in Agriculture?
Offer a terse response. -36.41. In the year 1969, what is the difference between the Value added (% of GDP) in Industry and Value added (% of GDP) in Manufacturing?
Make the answer very short. 6.87. In the year 1969, what is the difference between the Value added (% of GDP) of Industry and Value added (% of GDP) of Services?
Provide a short and direct response. -9.72. In the year 1969, what is the difference between the Value added (% of GDP) of Industry and Value added (% of GDP) of Agriculture?
Keep it short and to the point. -45.68. In the year 1969, what is the difference between the Value added (% of GDP) of Manufacturing and Value added (% of GDP) of Services?
Your answer should be very brief. -16.59. In the year 1969, what is the difference between the Value added (% of GDP) in Manufacturing and Value added (% of GDP) in Agriculture?
Keep it short and to the point. -52.55. In the year 1969, what is the difference between the Value added (% of GDP) in Services and Value added (% of GDP) in Agriculture?
Your response must be concise. -35.96. In the year 1970, what is the difference between the Value added (% of GDP) of Industry and Value added (% of GDP) of Manufacturing?
Provide a short and direct response. 6.63. In the year 1970, what is the difference between the Value added (% of GDP) of Industry and Value added (% of GDP) of Services?
Give a very brief answer. -8.79. In the year 1970, what is the difference between the Value added (% of GDP) of Industry and Value added (% of GDP) of Agriculture?
Your answer should be compact. -43.45. In the year 1970, what is the difference between the Value added (% of GDP) in Manufacturing and Value added (% of GDP) in Services?
Your answer should be compact. -15.42. In the year 1970, what is the difference between the Value added (% of GDP) in Manufacturing and Value added (% of GDP) in Agriculture?
Make the answer very short. -50.08. In the year 1970, what is the difference between the Value added (% of GDP) in Services and Value added (% of GDP) in Agriculture?
Keep it short and to the point. -34.66. In the year 1971, what is the difference between the Value added (% of GDP) in Industry and Value added (% of GDP) in Manufacturing?
Offer a very short reply. 6.99. In the year 1971, what is the difference between the Value added (% of GDP) of Industry and Value added (% of GDP) of Services?
Give a very brief answer. -8.32. In the year 1971, what is the difference between the Value added (% of GDP) of Industry and Value added (% of GDP) of Agriculture?
Offer a very short reply. -40.34. In the year 1971, what is the difference between the Value added (% of GDP) of Manufacturing and Value added (% of GDP) of Services?
Keep it short and to the point. -15.31. In the year 1971, what is the difference between the Value added (% of GDP) of Manufacturing and Value added (% of GDP) of Agriculture?
Make the answer very short. -47.33. In the year 1971, what is the difference between the Value added (% of GDP) of Services and Value added (% of GDP) of Agriculture?
Your response must be concise. -32.02. What is the ratio of the Value added (% of GDP) of Industry in 1964 to that in 1965?
Provide a succinct answer. 1.12. What is the ratio of the Value added (% of GDP) of Manufacturing in 1964 to that in 1965?
Offer a terse response. 1.05. What is the ratio of the Value added (% of GDP) of Services in 1964 to that in 1965?
Provide a succinct answer. 0.94. What is the ratio of the Value added (% of GDP) of Agriculture in 1964 to that in 1965?
Offer a terse response. 1.01. What is the ratio of the Value added (% of GDP) of Industry in 1964 to that in 1966?
Ensure brevity in your answer.  0.79. What is the ratio of the Value added (% of GDP) of Manufacturing in 1964 to that in 1966?
Ensure brevity in your answer.  0.57. What is the ratio of the Value added (% of GDP) of Services in 1964 to that in 1966?
Provide a short and direct response. 0.97. What is the ratio of the Value added (% of GDP) of Agriculture in 1964 to that in 1966?
Provide a succinct answer. 1.03. What is the ratio of the Value added (% of GDP) in Industry in 1964 to that in 1967?
Give a very brief answer. 0.72. What is the ratio of the Value added (% of GDP) in Manufacturing in 1964 to that in 1967?
Provide a succinct answer. 0.48. What is the ratio of the Value added (% of GDP) in Services in 1964 to that in 1967?
Your answer should be very brief. 0.9. What is the ratio of the Value added (% of GDP) of Agriculture in 1964 to that in 1967?
Offer a very short reply. 1.07. What is the ratio of the Value added (% of GDP) of Industry in 1964 to that in 1968?
Your response must be concise. 0.48. What is the ratio of the Value added (% of GDP) of Manufacturing in 1964 to that in 1968?
Your answer should be very brief. 0.43. What is the ratio of the Value added (% of GDP) of Services in 1964 to that in 1968?
Ensure brevity in your answer.  0.89. What is the ratio of the Value added (% of GDP) in Agriculture in 1964 to that in 1968?
Your response must be concise. 1.16. What is the ratio of the Value added (% of GDP) of Industry in 1964 to that in 1969?
Offer a terse response. 0.43. What is the ratio of the Value added (% of GDP) in Manufacturing in 1964 to that in 1969?
Your answer should be compact. 0.33. What is the ratio of the Value added (% of GDP) in Services in 1964 to that in 1969?
Provide a succinct answer. 0.91. What is the ratio of the Value added (% of GDP) in Agriculture in 1964 to that in 1969?
Your answer should be compact. 1.18. What is the ratio of the Value added (% of GDP) in Industry in 1964 to that in 1970?
Ensure brevity in your answer.  0.4. What is the ratio of the Value added (% of GDP) of Manufacturing in 1964 to that in 1970?
Provide a succinct answer. 0.28. What is the ratio of the Value added (% of GDP) of Services in 1964 to that in 1970?
Your answer should be compact. 0.91. What is the ratio of the Value added (% of GDP) in Agriculture in 1964 to that in 1970?
Your response must be concise. 1.2. What is the ratio of the Value added (% of GDP) in Industry in 1964 to that in 1971?
Your answer should be compact. 0.38. What is the ratio of the Value added (% of GDP) in Manufacturing in 1964 to that in 1971?
Keep it short and to the point. 0.26. What is the ratio of the Value added (% of GDP) in Services in 1964 to that in 1971?
Your response must be concise. 0.88. What is the ratio of the Value added (% of GDP) in Agriculture in 1964 to that in 1971?
Your answer should be very brief. 1.24. What is the ratio of the Value added (% of GDP) of Industry in 1965 to that in 1966?
Provide a short and direct response. 0.71. What is the ratio of the Value added (% of GDP) in Manufacturing in 1965 to that in 1966?
Ensure brevity in your answer.  0.54. What is the ratio of the Value added (% of GDP) in Services in 1965 to that in 1966?
Make the answer very short. 1.03. What is the ratio of the Value added (% of GDP) of Agriculture in 1965 to that in 1966?
Make the answer very short. 1.03. What is the ratio of the Value added (% of GDP) in Industry in 1965 to that in 1967?
Provide a short and direct response. 0.65. What is the ratio of the Value added (% of GDP) in Manufacturing in 1965 to that in 1967?
Offer a terse response. 0.45. What is the ratio of the Value added (% of GDP) in Services in 1965 to that in 1967?
Make the answer very short. 0.96. What is the ratio of the Value added (% of GDP) in Agriculture in 1965 to that in 1967?
Offer a very short reply. 1.06. What is the ratio of the Value added (% of GDP) in Industry in 1965 to that in 1968?
Provide a short and direct response. 0.43. What is the ratio of the Value added (% of GDP) in Manufacturing in 1965 to that in 1968?
Provide a succinct answer. 0.4. What is the ratio of the Value added (% of GDP) of Services in 1965 to that in 1968?
Your answer should be compact. 0.95. What is the ratio of the Value added (% of GDP) in Agriculture in 1965 to that in 1968?
Make the answer very short. 1.15. What is the ratio of the Value added (% of GDP) of Industry in 1965 to that in 1969?
Your response must be concise. 0.39. What is the ratio of the Value added (% of GDP) in Manufacturing in 1965 to that in 1969?
Give a very brief answer. 0.31. What is the ratio of the Value added (% of GDP) in Services in 1965 to that in 1969?
Provide a succinct answer. 0.97. What is the ratio of the Value added (% of GDP) in Agriculture in 1965 to that in 1969?
Offer a very short reply. 1.17. What is the ratio of the Value added (% of GDP) in Industry in 1965 to that in 1970?
Offer a very short reply. 0.36. What is the ratio of the Value added (% of GDP) in Manufacturing in 1965 to that in 1970?
Ensure brevity in your answer.  0.27. What is the ratio of the Value added (% of GDP) of Services in 1965 to that in 1970?
Keep it short and to the point. 0.96. What is the ratio of the Value added (% of GDP) in Agriculture in 1965 to that in 1970?
Your answer should be very brief. 1.19. What is the ratio of the Value added (% of GDP) in Industry in 1965 to that in 1971?
Ensure brevity in your answer.  0.34. What is the ratio of the Value added (% of GDP) of Manufacturing in 1965 to that in 1971?
Your response must be concise. 0.25. What is the ratio of the Value added (% of GDP) of Services in 1965 to that in 1971?
Ensure brevity in your answer.  0.93. What is the ratio of the Value added (% of GDP) in Agriculture in 1965 to that in 1971?
Provide a succinct answer. 1.23. What is the ratio of the Value added (% of GDP) of Industry in 1966 to that in 1967?
Your response must be concise. 0.92. What is the ratio of the Value added (% of GDP) of Manufacturing in 1966 to that in 1967?
Offer a very short reply. 0.83. What is the ratio of the Value added (% of GDP) of Services in 1966 to that in 1967?
Keep it short and to the point. 0.93. What is the ratio of the Value added (% of GDP) in Agriculture in 1966 to that in 1967?
Make the answer very short. 1.04. What is the ratio of the Value added (% of GDP) of Industry in 1966 to that in 1968?
Offer a terse response. 0.61. What is the ratio of the Value added (% of GDP) of Manufacturing in 1966 to that in 1968?
Offer a terse response. 0.74. What is the ratio of the Value added (% of GDP) in Services in 1966 to that in 1968?
Keep it short and to the point. 0.92. What is the ratio of the Value added (% of GDP) in Agriculture in 1966 to that in 1968?
Provide a succinct answer. 1.12. What is the ratio of the Value added (% of GDP) of Industry in 1966 to that in 1969?
Your answer should be compact. 0.55. What is the ratio of the Value added (% of GDP) of Manufacturing in 1966 to that in 1969?
Make the answer very short. 0.58. What is the ratio of the Value added (% of GDP) of Services in 1966 to that in 1969?
Your response must be concise. 0.94. What is the ratio of the Value added (% of GDP) of Agriculture in 1966 to that in 1969?
Offer a terse response. 1.14. What is the ratio of the Value added (% of GDP) of Industry in 1966 to that in 1970?
Offer a very short reply. 0.51. What is the ratio of the Value added (% of GDP) in Manufacturing in 1966 to that in 1970?
Provide a short and direct response. 0.5. What is the ratio of the Value added (% of GDP) of Services in 1966 to that in 1970?
Your answer should be compact. 0.93. What is the ratio of the Value added (% of GDP) of Agriculture in 1966 to that in 1970?
Make the answer very short. 1.16. What is the ratio of the Value added (% of GDP) in Industry in 1966 to that in 1971?
Offer a very short reply. 0.47. What is the ratio of the Value added (% of GDP) of Manufacturing in 1966 to that in 1971?
Offer a terse response. 0.46. What is the ratio of the Value added (% of GDP) of Services in 1966 to that in 1971?
Keep it short and to the point. 0.91. What is the ratio of the Value added (% of GDP) of Agriculture in 1966 to that in 1971?
Provide a short and direct response. 1.2. What is the ratio of the Value added (% of GDP) in Industry in 1967 to that in 1968?
Offer a terse response. 0.66. What is the ratio of the Value added (% of GDP) of Manufacturing in 1967 to that in 1968?
Keep it short and to the point. 0.89. What is the ratio of the Value added (% of GDP) in Services in 1967 to that in 1968?
Provide a short and direct response. 0.99. What is the ratio of the Value added (% of GDP) in Agriculture in 1967 to that in 1968?
Offer a very short reply. 1.08. What is the ratio of the Value added (% of GDP) in Industry in 1967 to that in 1969?
Ensure brevity in your answer.  0.6. What is the ratio of the Value added (% of GDP) of Manufacturing in 1967 to that in 1969?
Offer a terse response. 0.69. What is the ratio of the Value added (% of GDP) of Services in 1967 to that in 1969?
Offer a terse response. 1.01. What is the ratio of the Value added (% of GDP) in Agriculture in 1967 to that in 1969?
Your response must be concise. 1.09. What is the ratio of the Value added (% of GDP) in Industry in 1967 to that in 1970?
Ensure brevity in your answer.  0.56. What is the ratio of the Value added (% of GDP) of Manufacturing in 1967 to that in 1970?
Keep it short and to the point. 0.6. What is the ratio of the Value added (% of GDP) in Services in 1967 to that in 1970?
Your response must be concise. 1.01. What is the ratio of the Value added (% of GDP) in Agriculture in 1967 to that in 1970?
Your answer should be very brief. 1.12. What is the ratio of the Value added (% of GDP) in Industry in 1967 to that in 1971?
Provide a short and direct response. 0.52. What is the ratio of the Value added (% of GDP) in Manufacturing in 1967 to that in 1971?
Your response must be concise. 0.55. What is the ratio of the Value added (% of GDP) of Services in 1967 to that in 1971?
Your response must be concise. 0.98. What is the ratio of the Value added (% of GDP) in Agriculture in 1967 to that in 1971?
Provide a succinct answer. 1.15. What is the ratio of the Value added (% of GDP) of Industry in 1968 to that in 1969?
Your answer should be compact. 0.9. What is the ratio of the Value added (% of GDP) in Manufacturing in 1968 to that in 1969?
Provide a succinct answer. 0.78. What is the ratio of the Value added (% of GDP) of Services in 1968 to that in 1969?
Your answer should be compact. 1.02. What is the ratio of the Value added (% of GDP) in Agriculture in 1968 to that in 1969?
Give a very brief answer. 1.02. What is the ratio of the Value added (% of GDP) in Industry in 1968 to that in 1970?
Provide a succinct answer. 0.84. What is the ratio of the Value added (% of GDP) of Manufacturing in 1968 to that in 1970?
Give a very brief answer. 0.67. What is the ratio of the Value added (% of GDP) in Services in 1968 to that in 1970?
Offer a terse response. 1.02. What is the ratio of the Value added (% of GDP) in Agriculture in 1968 to that in 1970?
Provide a succinct answer. 1.04. What is the ratio of the Value added (% of GDP) in Industry in 1968 to that in 1971?
Make the answer very short. 0.78. What is the ratio of the Value added (% of GDP) of Manufacturing in 1968 to that in 1971?
Keep it short and to the point. 0.61. What is the ratio of the Value added (% of GDP) in Services in 1968 to that in 1971?
Your response must be concise. 0.99. What is the ratio of the Value added (% of GDP) of Agriculture in 1968 to that in 1971?
Give a very brief answer. 1.07. What is the ratio of the Value added (% of GDP) in Industry in 1969 to that in 1970?
Provide a short and direct response. 0.93. What is the ratio of the Value added (% of GDP) in Manufacturing in 1969 to that in 1970?
Offer a terse response. 0.86. What is the ratio of the Value added (% of GDP) in Services in 1969 to that in 1970?
Your answer should be very brief. 0.99. What is the ratio of the Value added (% of GDP) of Agriculture in 1969 to that in 1970?
Offer a very short reply. 1.02. What is the ratio of the Value added (% of GDP) of Industry in 1969 to that in 1971?
Your answer should be compact. 0.87. What is the ratio of the Value added (% of GDP) of Manufacturing in 1969 to that in 1971?
Give a very brief answer. 0.79. What is the ratio of the Value added (% of GDP) of Services in 1969 to that in 1971?
Keep it short and to the point. 0.97. What is the ratio of the Value added (% of GDP) of Agriculture in 1969 to that in 1971?
Ensure brevity in your answer.  1.05. What is the ratio of the Value added (% of GDP) of Industry in 1970 to that in 1971?
Give a very brief answer. 0.93. What is the ratio of the Value added (% of GDP) in Manufacturing in 1970 to that in 1971?
Your response must be concise. 0.92. What is the ratio of the Value added (% of GDP) of Services in 1970 to that in 1971?
Make the answer very short. 0.97. What is the ratio of the Value added (% of GDP) of Agriculture in 1970 to that in 1971?
Keep it short and to the point. 1.03. What is the difference between the highest and the second highest Value added (% of GDP) of Industry?
Provide a succinct answer. 1.2. What is the difference between the highest and the second highest Value added (% of GDP) in Manufacturing?
Offer a very short reply. 0.83. What is the difference between the highest and the second highest Value added (% of GDP) in Services?
Offer a terse response. 0.34. What is the difference between the highest and the second highest Value added (% of GDP) of Agriculture?
Offer a terse response. 0.65. What is the difference between the highest and the lowest Value added (% of GDP) in Industry?
Make the answer very short. 11.38. What is the difference between the highest and the lowest Value added (% of GDP) in Manufacturing?
Offer a very short reply. 7.61. What is the difference between the highest and the lowest Value added (% of GDP) in Services?
Give a very brief answer. 3.04. What is the difference between the highest and the lowest Value added (% of GDP) of Agriculture?
Your answer should be very brief. 13.74. 